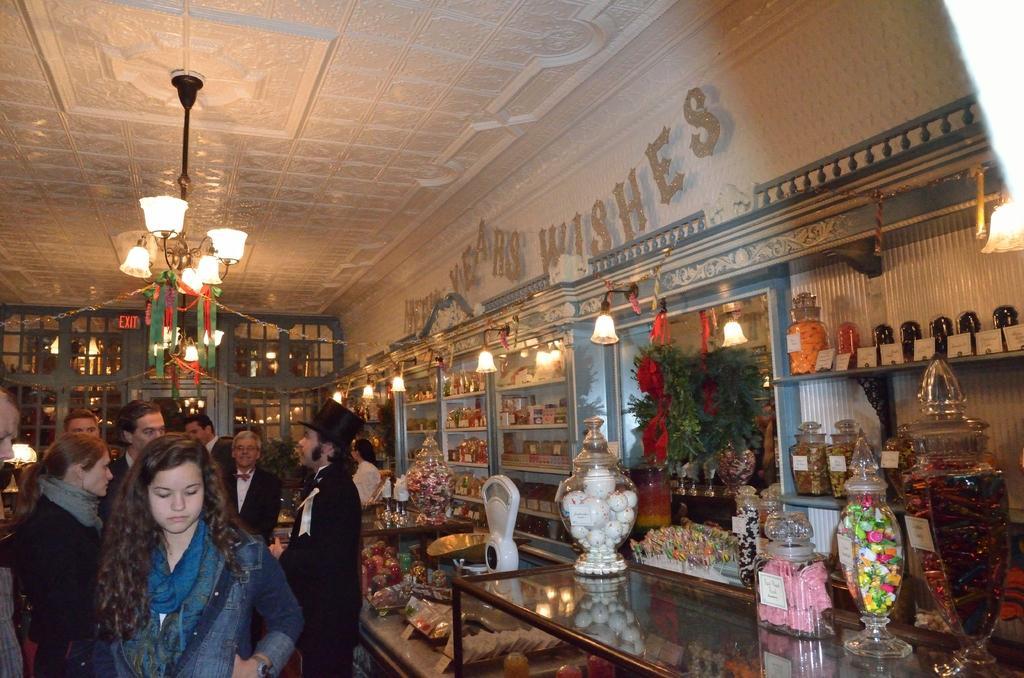Can you describe this image briefly? This picture describes about group of people, beside to them we can find few jars, weighing machine and other things on the tables, in this we can find few plants and lights, and also we can find few bottles and other things in the racks. 